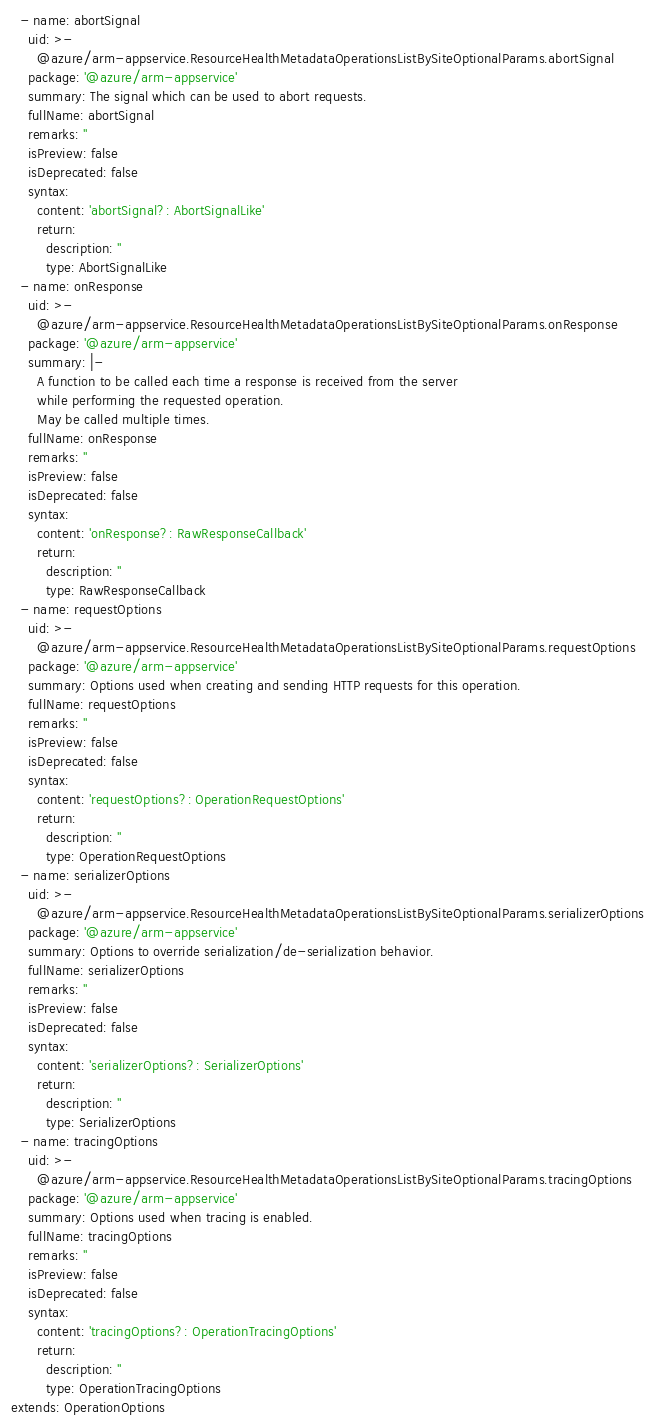Convert code to text. <code><loc_0><loc_0><loc_500><loc_500><_YAML_>  - name: abortSignal
    uid: >-
      @azure/arm-appservice.ResourceHealthMetadataOperationsListBySiteOptionalParams.abortSignal
    package: '@azure/arm-appservice'
    summary: The signal which can be used to abort requests.
    fullName: abortSignal
    remarks: ''
    isPreview: false
    isDeprecated: false
    syntax:
      content: 'abortSignal?: AbortSignalLike'
      return:
        description: ''
        type: AbortSignalLike
  - name: onResponse
    uid: >-
      @azure/arm-appservice.ResourceHealthMetadataOperationsListBySiteOptionalParams.onResponse
    package: '@azure/arm-appservice'
    summary: |-
      A function to be called each time a response is received from the server
      while performing the requested operation.
      May be called multiple times.
    fullName: onResponse
    remarks: ''
    isPreview: false
    isDeprecated: false
    syntax:
      content: 'onResponse?: RawResponseCallback'
      return:
        description: ''
        type: RawResponseCallback
  - name: requestOptions
    uid: >-
      @azure/arm-appservice.ResourceHealthMetadataOperationsListBySiteOptionalParams.requestOptions
    package: '@azure/arm-appservice'
    summary: Options used when creating and sending HTTP requests for this operation.
    fullName: requestOptions
    remarks: ''
    isPreview: false
    isDeprecated: false
    syntax:
      content: 'requestOptions?: OperationRequestOptions'
      return:
        description: ''
        type: OperationRequestOptions
  - name: serializerOptions
    uid: >-
      @azure/arm-appservice.ResourceHealthMetadataOperationsListBySiteOptionalParams.serializerOptions
    package: '@azure/arm-appservice'
    summary: Options to override serialization/de-serialization behavior.
    fullName: serializerOptions
    remarks: ''
    isPreview: false
    isDeprecated: false
    syntax:
      content: 'serializerOptions?: SerializerOptions'
      return:
        description: ''
        type: SerializerOptions
  - name: tracingOptions
    uid: >-
      @azure/arm-appservice.ResourceHealthMetadataOperationsListBySiteOptionalParams.tracingOptions
    package: '@azure/arm-appservice'
    summary: Options used when tracing is enabled.
    fullName: tracingOptions
    remarks: ''
    isPreview: false
    isDeprecated: false
    syntax:
      content: 'tracingOptions?: OperationTracingOptions'
      return:
        description: ''
        type: OperationTracingOptions
extends: OperationOptions
</code> 